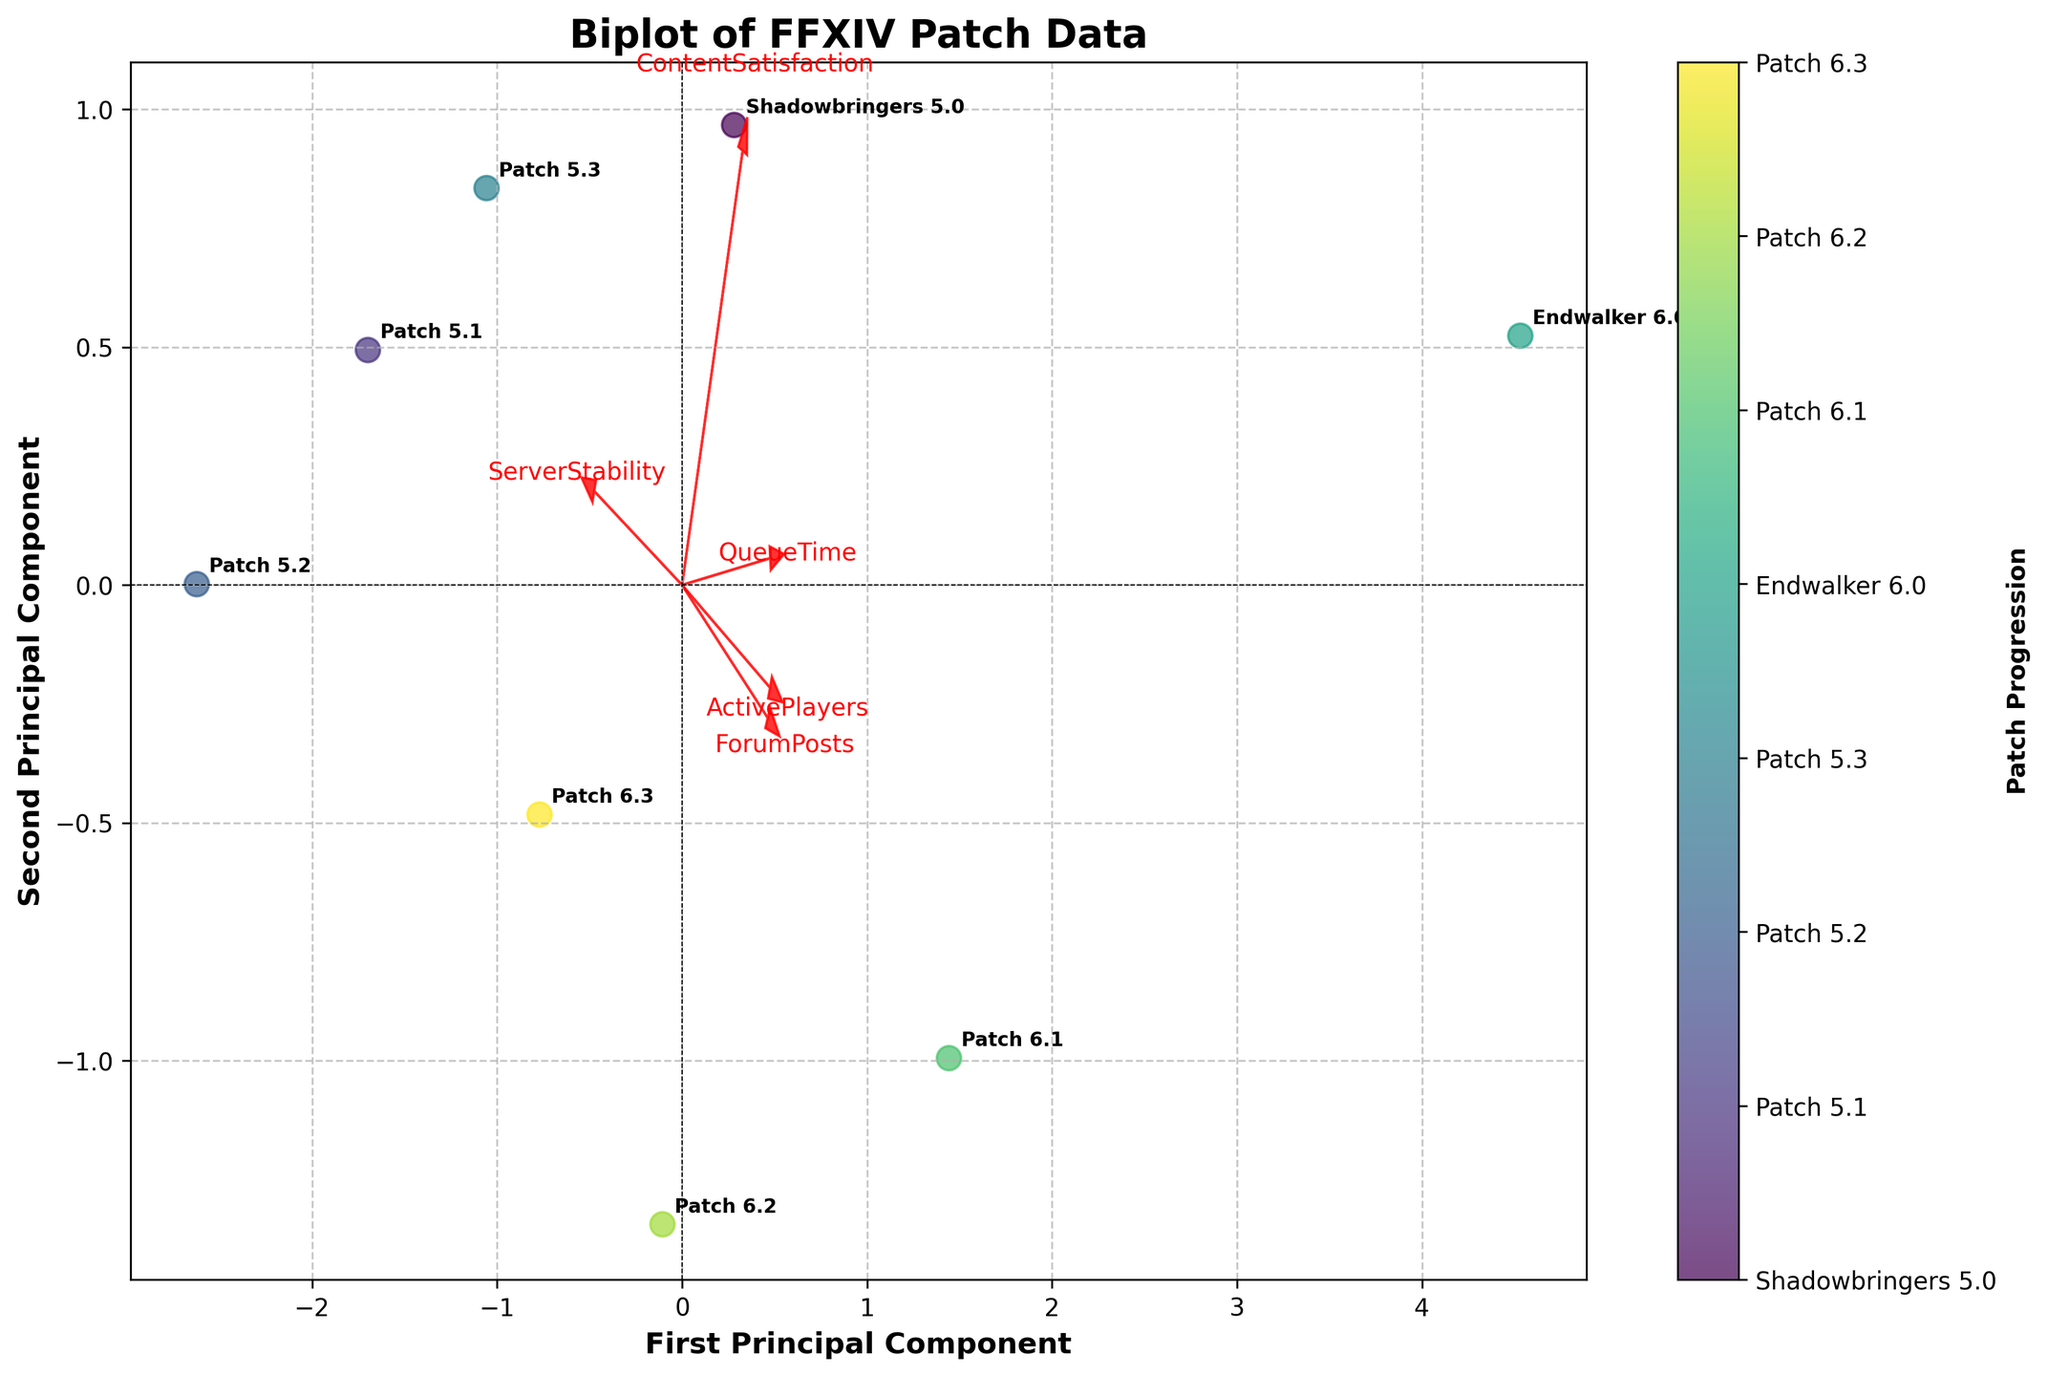Which patch has the highest value on the first principal component? We can determine this by looking at the position of the patches along the x-axis in the biplot. The patch furthest to the right has the highest value.
Answer: Endwalker 6.0 What does the arrow labeled 'QueueTime' indicate about this feature's relationship to the first principal component? The direction and length of the arrow show the strength and direction of the relationship. An arrow pointing right and being longer indicates a strong positive correlation with the first principal component.
Answer: Strong positive correlation How are 'ActivePlayers' and 'ServerStability' related according to the biplot? The arrows for 'ActivePlayers' and 'ServerStability' are almost in opposite directions, suggesting that these features are negatively correlated.
Answer: Negatively correlated Which feature is most strongly associated with the second principal component? The feature with the arrow most aligned along the y-axis (second principal component) is 'ServerStability'.
Answer: ServerStability Is 'ContentSatisfaction' more related to the first or second principal component? By observing the orientation of the arrow for 'ContentSatisfaction', it is closer to the x-axis (first principal component) than the y-axis (second principal component).
Answer: First principal component Which patch has lower values for both principal components? The patch located towards the bottom-left corner of the biplot has lower values for both principal components.
Answer: Patch 5.2 What is the relationship between 'ForumPosts' and the patches' queue times? If 'ForumPosts' arrow points in the same direction as 'QueueTime' and both are positively correlated with the first component, they are likely positively correlated with each other.
Answer: Positively correlated Which features are positively correlated with each other? Positive correlation is indicated by arrows that point in the same or similar direction. 'QueueTime' and 'ForumPosts' arrows point similarly, suggesting a positive correlation.
Answer: QueueTime and ForumPosts Are 'ServerStability' and 'ForumPosts' likely to be correlated? The arrows for 'ServerStability' and 'ForumPosts' point almost opposite each other, indicating a likely negative correlation.
Answer: Negatively correlated 